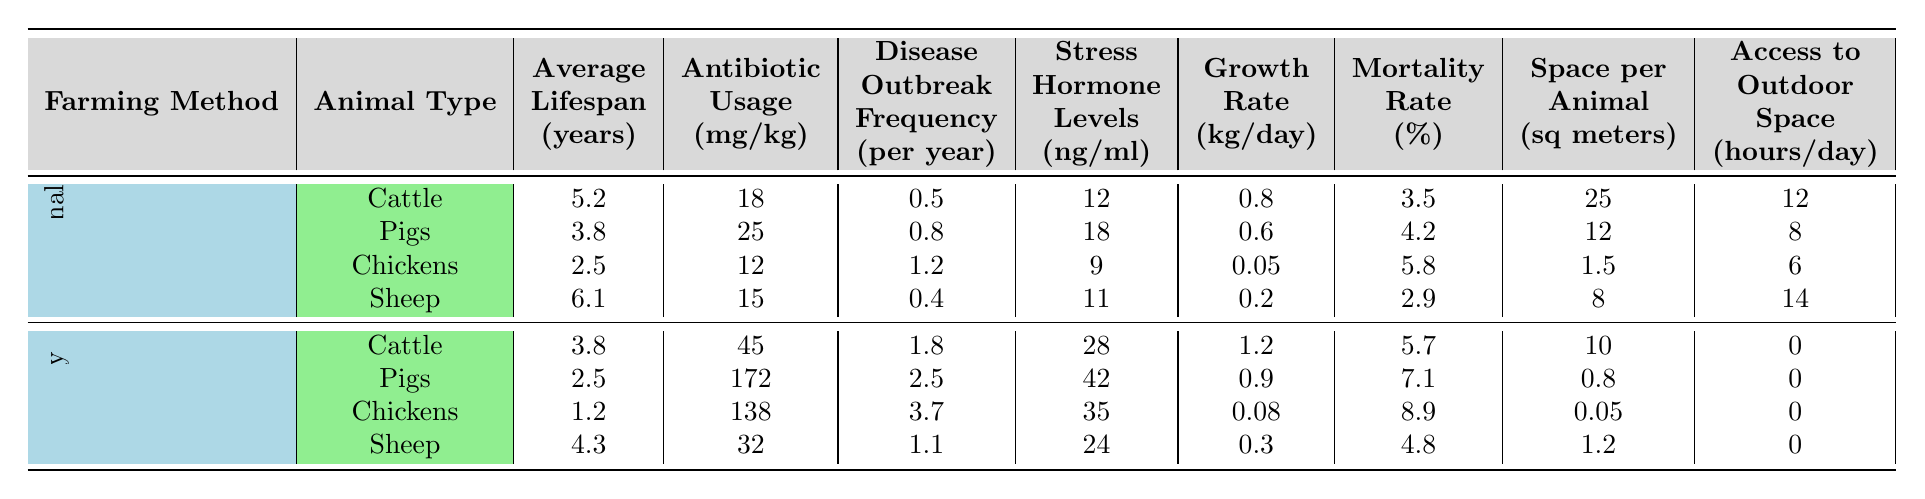What is the average lifespan of traditional chickens? Referring to the table, the average lifespan for traditional chickens is listed under the "Average Lifespan (years)" column as 2.5 years.
Answer: 2.5 years How much antibiotic usage is recorded for factory pigs? Looking at the table, the antibiotic usage for factory pigs is provided in the "Antibiotic Usage (mg/kg)" column as 172 mg/kg.
Answer: 172 mg/kg What is the disease outbreak frequency for traditional sheep? According to the table, traditional sheep have a disease outbreak frequency of 0.4 per year, as shown in the "Disease Outbreak Frequency (per year)" column.
Answer: 0.4 per year Which method has a higher mortality rate for cattle, traditional or factory? The mortality rate for traditional cattle is 3.5%, while for factory cattle it is 5.7%. Since 5.7% is greater than 3.5%, factory farming has a higher mortality rate for cattle.
Answer: Factory What is the percentage difference in stress hormone levels between factory and traditional pigs? The stress hormone levels for traditional pigs are 18 ng/ml, and for factory pigs, they are 42 ng/ml. The difference is 42 - 18 = 24 ng/ml. The percentage difference is calculated as (24 / 18) * 100 ≈ 133.33%.
Answer: Approximately 133.33% How does the average lifespan of traditional sheep compare to that of factory sheep? Traditional sheep have an average lifespan of 6.1 years, while factory sheep have 4.3 years. The comparison shows that traditional sheep live longer by 1.8 years (6.1 - 4.3).
Answer: Traditional sheep live longer by 1.8 years What is the space per animal for traditional chickens? In the table, under the column "Space per Animal (sq meters)," it indicates that traditional chickens have 1.5 sq meters of space per animal.
Answer: 1.5 sq meters Do factory chickens have access to any outdoor space? The table shows that factory chickens have 0 hours of access to outdoor space per day, indicating they do not have any outdoor access.
Answer: No How many animals for traditional farming have a growth rate above 0.5 kg/day? Traditional cattle (0.8 kg/day) and pigs (0.6 kg/day) both have a growth rate above 0.5 kg/day, while chickens (0.05 kg/day) and sheep (0.2 kg/day) do not. Therefore, there are 2 animals.
Answer: 2 animals Calculate the average antibiotic usage for traditional farming. For traditional farming, the antibiotic usage values are 18, 25, 12, and 15 mg/kg. The total is 18 + 25 + 12 + 15 = 70 mg/kg. There are 4 data points, so the average usage is 70 / 4 = 17.5 mg/kg.
Answer: 17.5 mg/kg What is the total average lifespan for all types of factory-farmed animals? The average lifespan values for factory-farmed animals are 3.8 (cattle), 2.5 (pigs), 1.2 (chickens), and 4.3 (sheep). Summing these gives 3.8 + 2.5 + 1.2 + 4.3 = 11.8 years. The average is then 11.8 / 4 = 2.95 years.
Answer: 2.95 years 